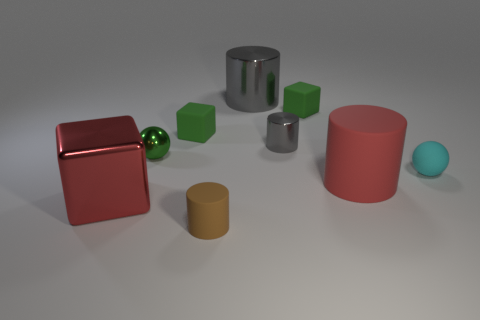Subtract all blue cylinders. How many green blocks are left? 2 Subtract all red cylinders. How many cylinders are left? 3 Subtract all matte cubes. How many cubes are left? 1 Add 1 cyan objects. How many objects exist? 10 Subtract all yellow cylinders. Subtract all blue blocks. How many cylinders are left? 4 Subtract all cubes. How many objects are left? 6 Subtract all cyan spheres. Subtract all matte blocks. How many objects are left? 6 Add 4 red matte things. How many red matte things are left? 5 Add 3 tiny metallic spheres. How many tiny metallic spheres exist? 4 Subtract 1 gray cylinders. How many objects are left? 8 